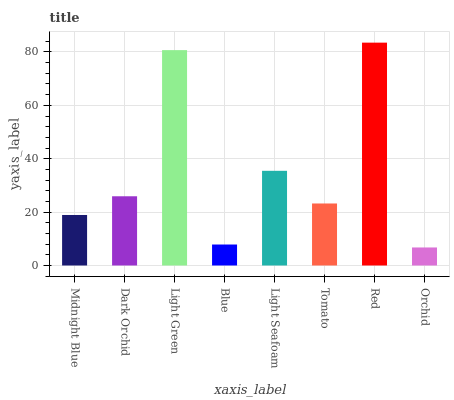Is Orchid the minimum?
Answer yes or no. Yes. Is Red the maximum?
Answer yes or no. Yes. Is Dark Orchid the minimum?
Answer yes or no. No. Is Dark Orchid the maximum?
Answer yes or no. No. Is Dark Orchid greater than Midnight Blue?
Answer yes or no. Yes. Is Midnight Blue less than Dark Orchid?
Answer yes or no. Yes. Is Midnight Blue greater than Dark Orchid?
Answer yes or no. No. Is Dark Orchid less than Midnight Blue?
Answer yes or no. No. Is Dark Orchid the high median?
Answer yes or no. Yes. Is Tomato the low median?
Answer yes or no. Yes. Is Red the high median?
Answer yes or no. No. Is Red the low median?
Answer yes or no. No. 